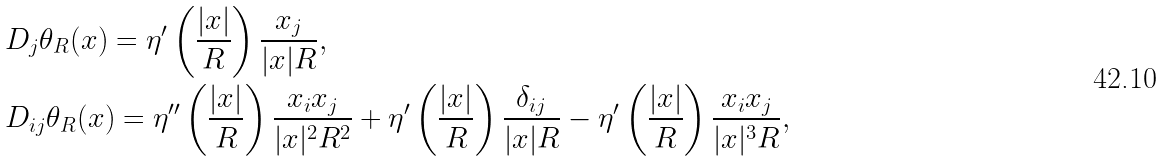Convert formula to latex. <formula><loc_0><loc_0><loc_500><loc_500>& D _ { j } \theta _ { R } ( x ) = \eta ^ { \prime } \left ( \frac { | x | } { R } \right ) \frac { x _ { j } } { | x | R } , \\ & D _ { i j } \theta _ { R } ( x ) = \eta ^ { \prime \prime } \left ( \frac { | x | } { R } \right ) \frac { x _ { i } x _ { j } } { | x | ^ { 2 } R ^ { 2 } } + \eta ^ { \prime } \left ( \frac { | x | } { R } \right ) \frac { \delta _ { i j } } { | x | R } - \eta ^ { \prime } \left ( \frac { | x | } { R } \right ) \frac { x _ { i } x _ { j } } { | x | ^ { 3 } R } ,</formula> 